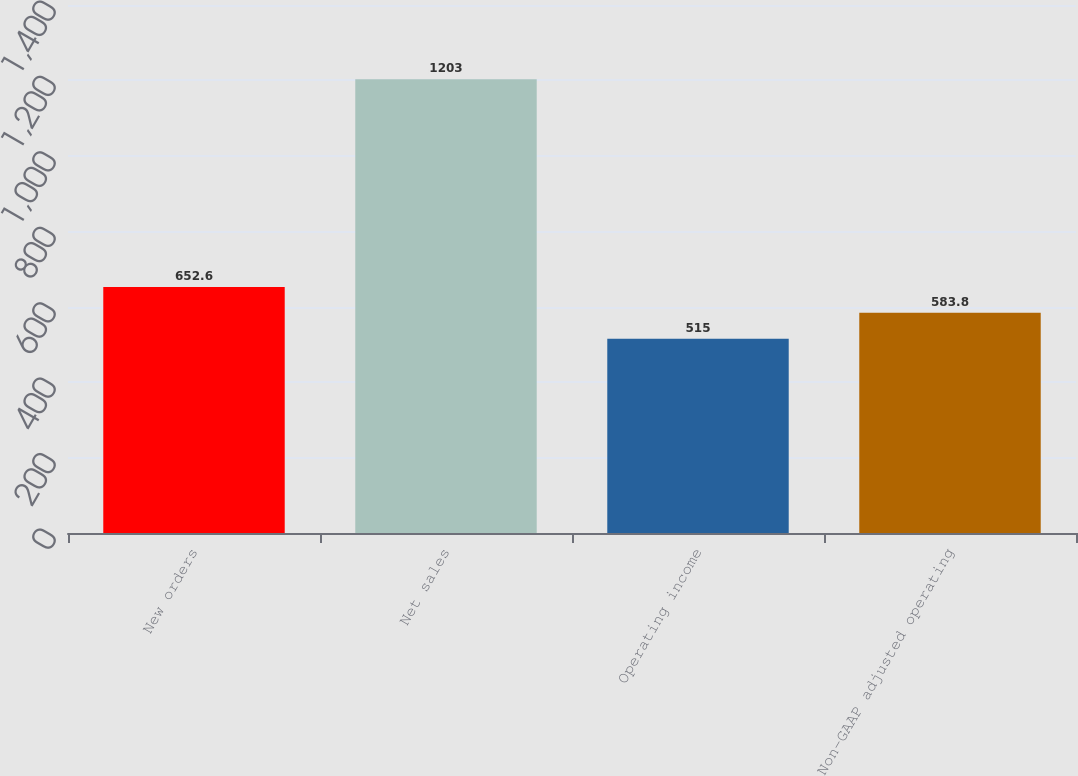Convert chart. <chart><loc_0><loc_0><loc_500><loc_500><bar_chart><fcel>New orders<fcel>Net sales<fcel>Operating income<fcel>Non-GAAP adjusted operating<nl><fcel>652.6<fcel>1203<fcel>515<fcel>583.8<nl></chart> 